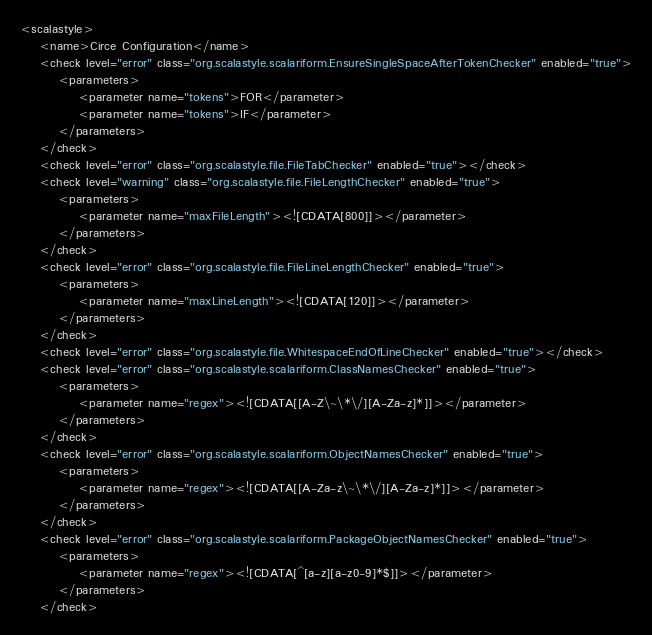<code> <loc_0><loc_0><loc_500><loc_500><_XML_><scalastyle>
    <name>Circe Configuration</name>
    <check level="error" class="org.scalastyle.scalariform.EnsureSingleSpaceAfterTokenChecker" enabled="true">
        <parameters>
            <parameter name="tokens">FOR</parameter>
            <parameter name="tokens">IF</parameter>
        </parameters>
    </check>
    <check level="error" class="org.scalastyle.file.FileTabChecker" enabled="true"></check>
    <check level="warning" class="org.scalastyle.file.FileLengthChecker" enabled="true">
        <parameters>
            <parameter name="maxFileLength"><![CDATA[800]]></parameter>
        </parameters>
    </check>
    <check level="error" class="org.scalastyle.file.FileLineLengthChecker" enabled="true">
        <parameters>
            <parameter name="maxLineLength"><![CDATA[120]]></parameter>
        </parameters>
    </check>
    <check level="error" class="org.scalastyle.file.WhitespaceEndOfLineChecker" enabled="true"></check>
    <check level="error" class="org.scalastyle.scalariform.ClassNamesChecker" enabled="true">
        <parameters>
            <parameter name="regex"><![CDATA[[A-Z\~\*\/][A-Za-z]*]]></parameter>
        </parameters>
    </check>
    <check level="error" class="org.scalastyle.scalariform.ObjectNamesChecker" enabled="true">
        <parameters>
            <parameter name="regex"><![CDATA[[A-Za-z\~\*\/][A-Za-z]*]]></parameter>
        </parameters>
    </check>
    <check level="error" class="org.scalastyle.scalariform.PackageObjectNamesChecker" enabled="true">
        <parameters>
            <parameter name="regex"><![CDATA[^[a-z][a-z0-9]*$]]></parameter>
        </parameters>
    </check></code> 